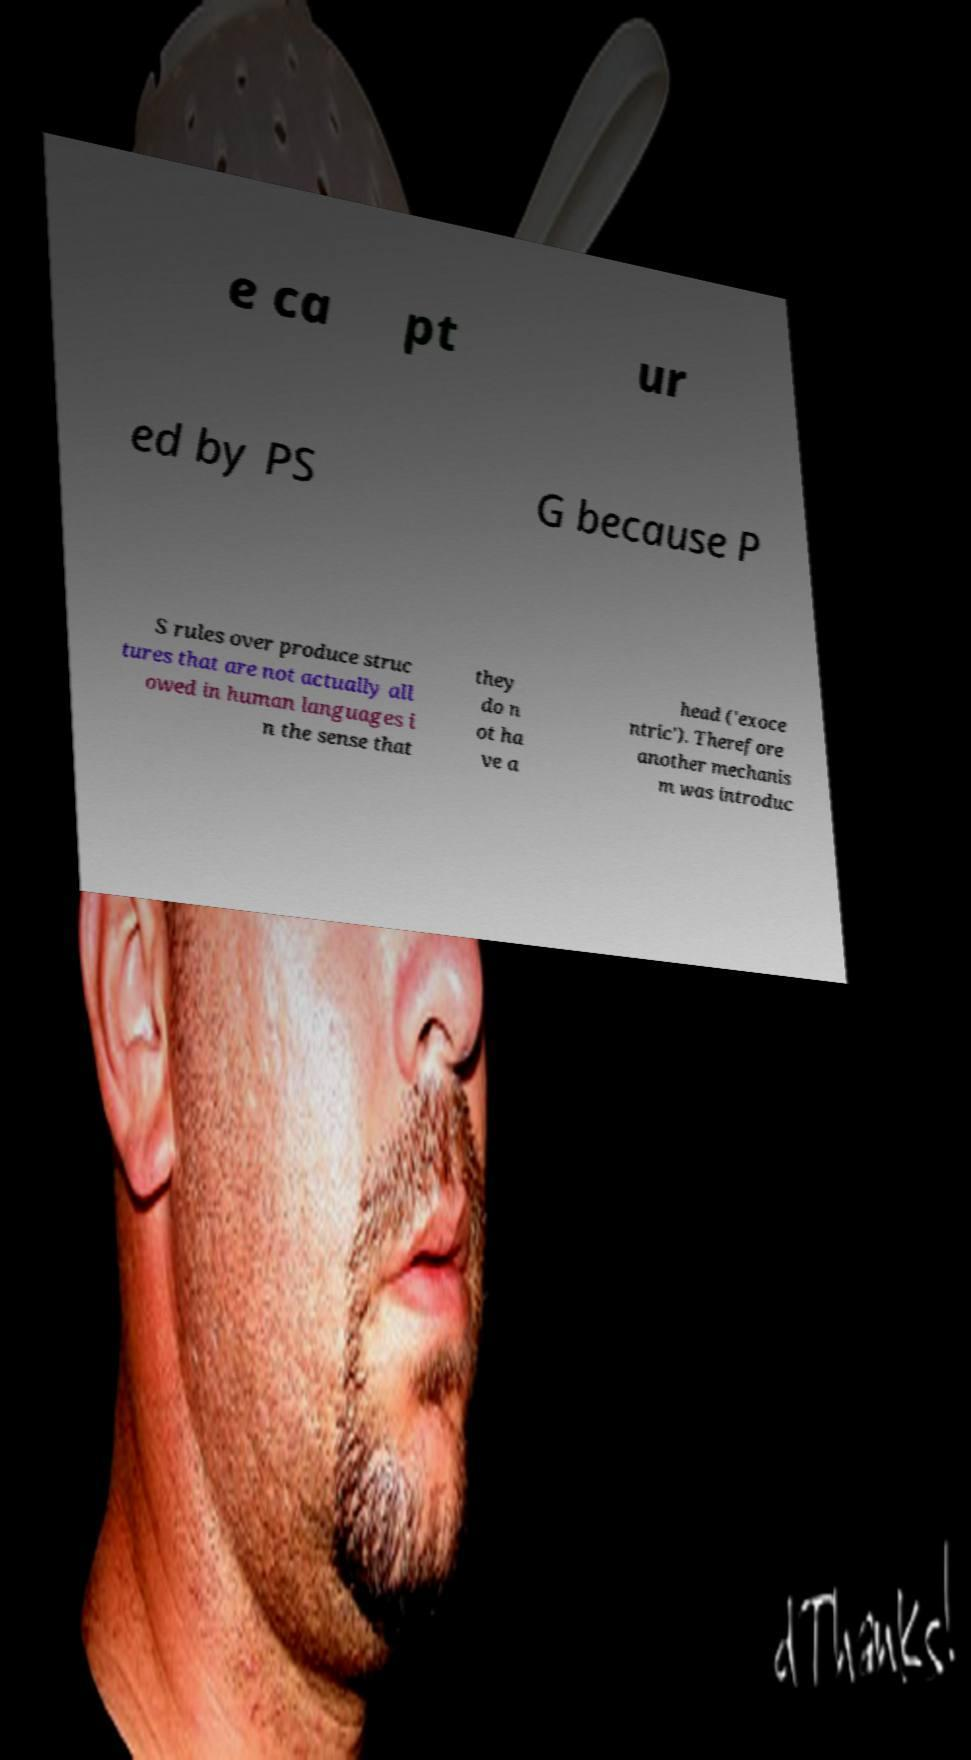Can you accurately transcribe the text from the provided image for me? e ca pt ur ed by PS G because P S rules over produce struc tures that are not actually all owed in human languages i n the sense that they do n ot ha ve a head ('exoce ntric'). Therefore another mechanis m was introduc 